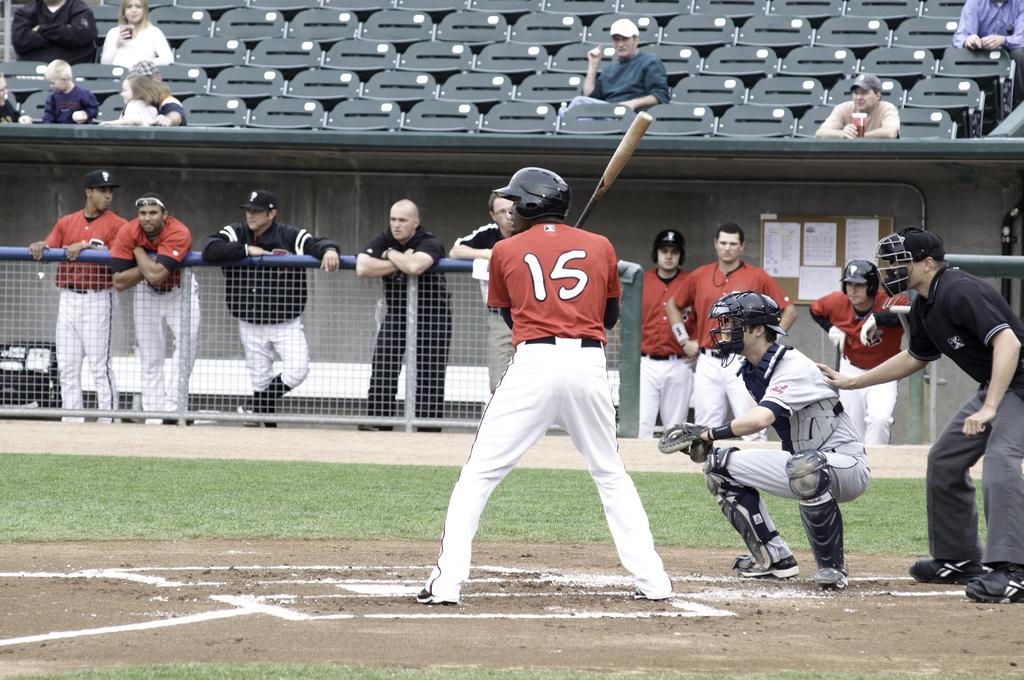Provide a one-sentence caption for the provided image. Number 15 digs into the box and prepares to take his at bat. 